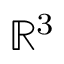Convert formula to latex. <formula><loc_0><loc_0><loc_500><loc_500>{ \mathbb { R } } ^ { 3 }</formula> 